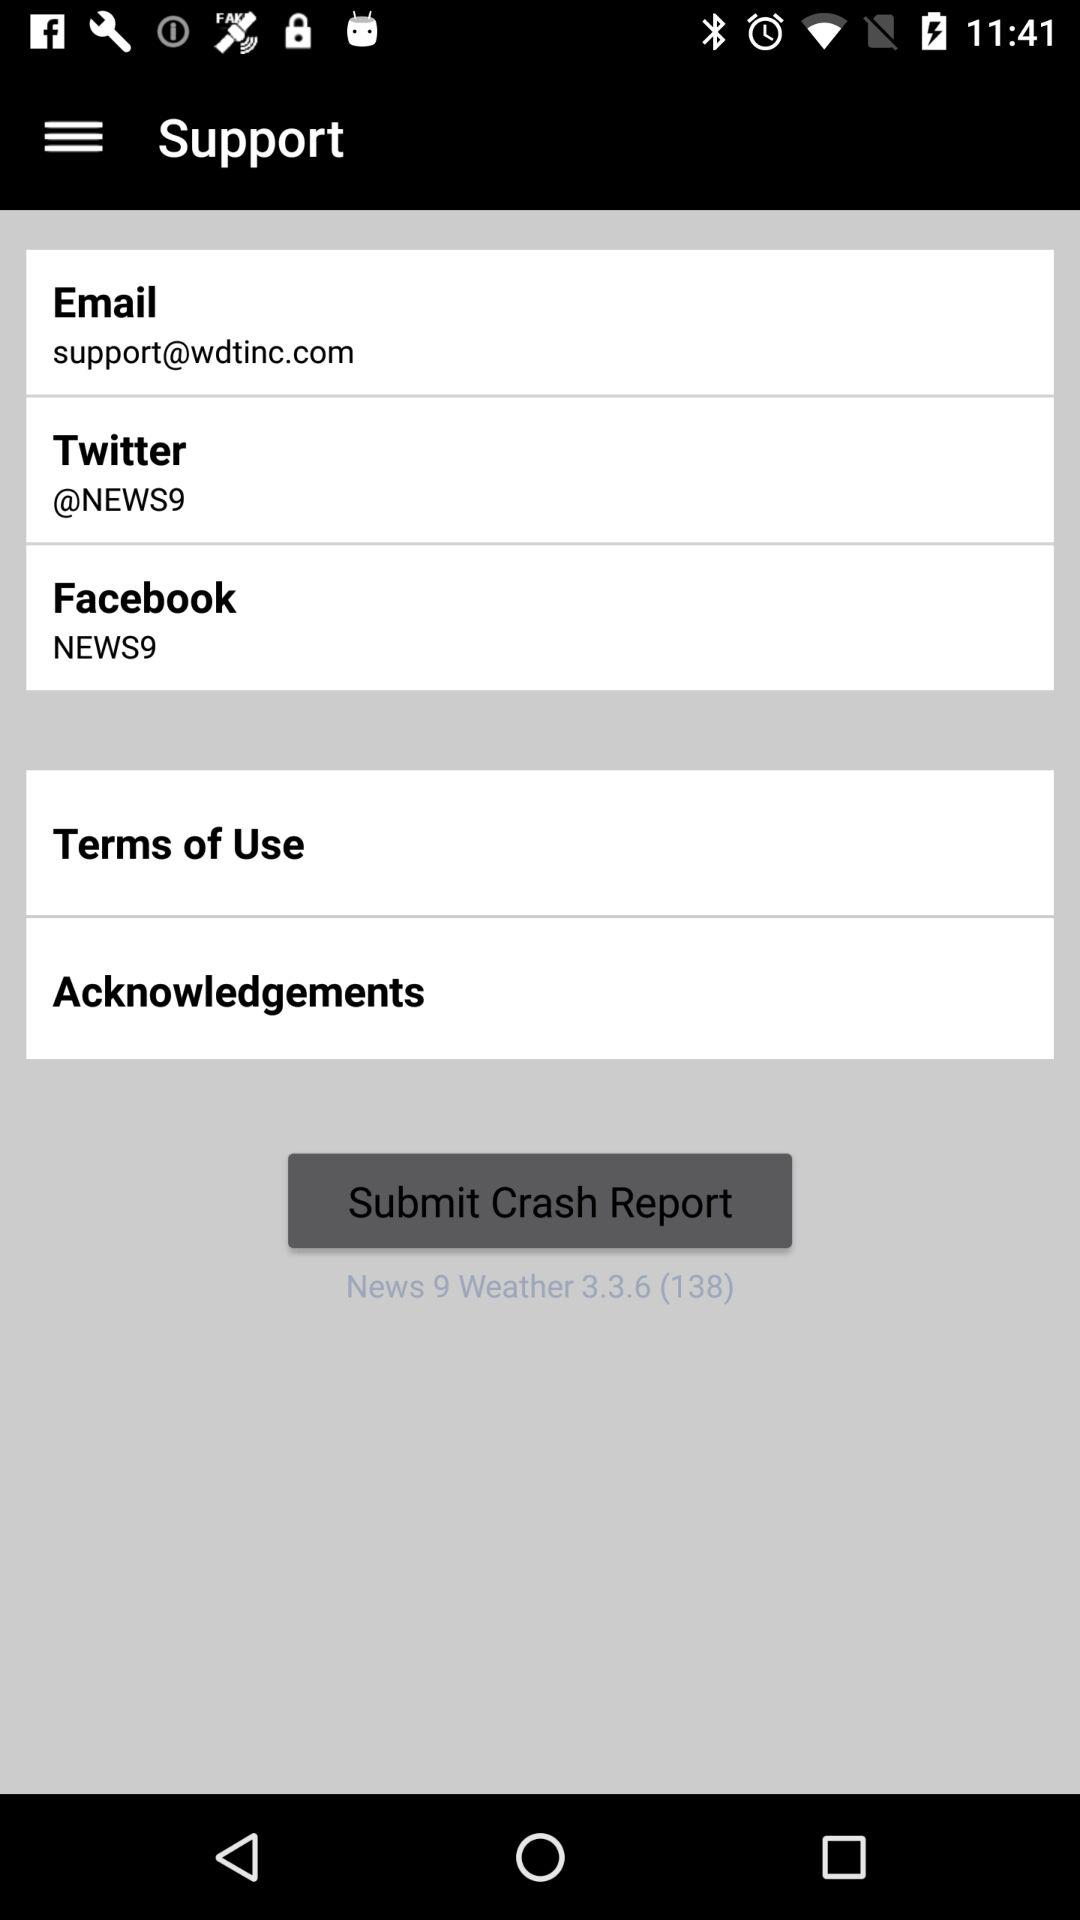How many more social media contact options are there than navigation options?
Answer the question using a single word or phrase. 2 